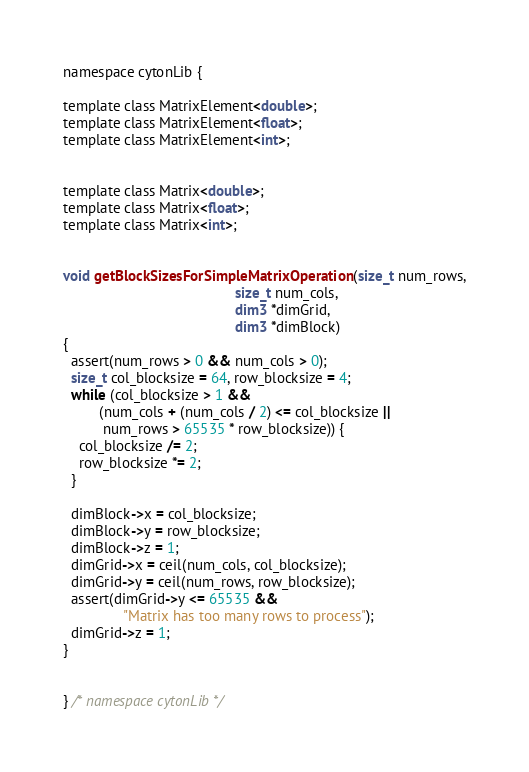<code> <loc_0><loc_0><loc_500><loc_500><_Cuda_>namespace cytonLib {

template class MatrixElement<double>;
template class MatrixElement<float>;
template class MatrixElement<int>;


template class Matrix<double>;
template class Matrix<float>;
template class Matrix<int>;


void getBlockSizesForSimpleMatrixOperation(size_t num_rows,
                                           size_t num_cols,
                                           dim3 *dimGrid,
                                           dim3 *dimBlock)
{
  assert(num_rows > 0 && num_cols > 0);
  size_t col_blocksize = 64, row_blocksize = 4;
  while (col_blocksize > 1 &&
         (num_cols + (num_cols / 2) <= col_blocksize ||
          num_rows > 65535 * row_blocksize)) {
    col_blocksize /= 2;
    row_blocksize *= 2;
  }

  dimBlock->x = col_blocksize;
  dimBlock->y = row_blocksize;
  dimBlock->z = 1;
  dimGrid->x = ceil(num_cols, col_blocksize);
  dimGrid->y = ceil(num_rows, row_blocksize);
  assert(dimGrid->y <= 65535 &&
               "Matrix has too many rows to process");
  dimGrid->z = 1;
}


} /* namespace cytonLib */
</code> 